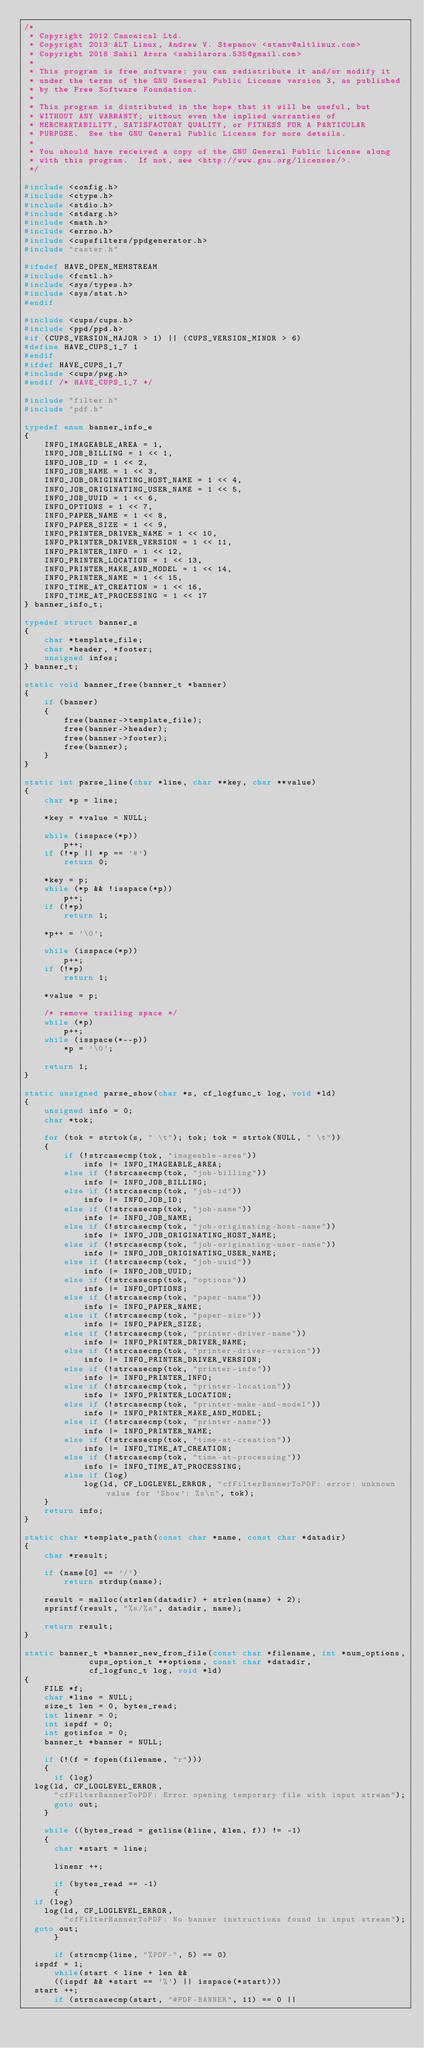Convert code to text. <code><loc_0><loc_0><loc_500><loc_500><_C_>/*
 * Copyright 2012 Canonical Ltd.
 * Copyright 2013 ALT Linux, Andrew V. Stepanov <stanv@altlinux.com>
 * Copyright 2018 Sahil Arora <sahilarora.535@gmail.com>
 *
 * This program is free software: you can redistribute it and/or modify it
 * under the terms of the GNU General Public License version 3, as published
 * by the Free Software Foundation.
 *
 * This program is distributed in the hope that it will be useful, but
 * WITHOUT ANY WARRANTY; without even the implied warranties of
 * MERCHANTABILITY, SATISFACTORY QUALITY, or FITNESS FOR A PARTICULAR
 * PURPOSE.  See the GNU General Public License for more details.
 *
 * You should have received a copy of the GNU General Public License along
 * with this program.  If not, see <http://www.gnu.org/licenses/>.
 */

#include <config.h>
#include <ctype.h>
#include <stdio.h>
#include <stdarg.h>
#include <math.h>
#include <errno.h>
#include <cupsfilters/ppdgenerator.h>
#include "raster.h"

#ifndef HAVE_OPEN_MEMSTREAM
#include <fcntl.h>
#include <sys/types.h>
#include <sys/stat.h>
#endif

#include <cups/cups.h>
#include <ppd/ppd.h>
#if (CUPS_VERSION_MAJOR > 1) || (CUPS_VERSION_MINOR > 6)
#define HAVE_CUPS_1_7 1
#endif
#ifdef HAVE_CUPS_1_7
#include <cups/pwg.h>
#endif /* HAVE_CUPS_1_7 */

#include "filter.h"
#include "pdf.h"

typedef enum banner_info_e
{
    INFO_IMAGEABLE_AREA = 1,
    INFO_JOB_BILLING = 1 << 1,
    INFO_JOB_ID = 1 << 2,
    INFO_JOB_NAME = 1 << 3,
    INFO_JOB_ORIGINATING_HOST_NAME = 1 << 4,
    INFO_JOB_ORIGINATING_USER_NAME = 1 << 5,
    INFO_JOB_UUID = 1 << 6,
    INFO_OPTIONS = 1 << 7,
    INFO_PAPER_NAME = 1 << 8,
    INFO_PAPER_SIZE = 1 << 9,
    INFO_PRINTER_DRIVER_NAME = 1 << 10,
    INFO_PRINTER_DRIVER_VERSION = 1 << 11,
    INFO_PRINTER_INFO = 1 << 12,
    INFO_PRINTER_LOCATION = 1 << 13,
    INFO_PRINTER_MAKE_AND_MODEL = 1 << 14,
    INFO_PRINTER_NAME = 1 << 15,
    INFO_TIME_AT_CREATION = 1 << 16,
    INFO_TIME_AT_PROCESSING = 1 << 17
} banner_info_t;

typedef struct banner_s
{
    char *template_file;
    char *header, *footer;
    unsigned infos;
} banner_t;

static void banner_free(banner_t *banner)
{
    if (banner)
    {
        free(banner->template_file);
        free(banner->header);
        free(banner->footer);
        free(banner);
    }
}

static int parse_line(char *line, char **key, char **value)
{
    char *p = line;

    *key = *value = NULL;

    while (isspace(*p))
        p++;
    if (!*p || *p == '#')
        return 0;

    *key = p;
    while (*p && !isspace(*p))
        p++;
    if (!*p)
        return 1;

    *p++ = '\0';

    while (isspace(*p))
        p++;
    if (!*p)
        return 1;

    *value = p;

    /* remove trailing space */
    while (*p)
        p++;
    while (isspace(*--p))
        *p = '\0';

    return 1;
}

static unsigned parse_show(char *s, cf_logfunc_t log, void *ld)
{
    unsigned info = 0;
    char *tok;

    for (tok = strtok(s, " \t"); tok; tok = strtok(NULL, " \t"))
    {
        if (!strcasecmp(tok, "imageable-area"))
            info |= INFO_IMAGEABLE_AREA;
        else if (!strcasecmp(tok, "job-billing"))
            info |= INFO_JOB_BILLING;
        else if (!strcasecmp(tok, "job-id"))
            info |= INFO_JOB_ID;
        else if (!strcasecmp(tok, "job-name"))
            info |= INFO_JOB_NAME;
        else if (!strcasecmp(tok, "job-originating-host-name"))
            info |= INFO_JOB_ORIGINATING_HOST_NAME;
        else if (!strcasecmp(tok, "job-originating-user-name"))
            info |= INFO_JOB_ORIGINATING_USER_NAME;
        else if (!strcasecmp(tok, "job-uuid"))
            info |= INFO_JOB_UUID;
        else if (!strcasecmp(tok, "options"))
            info |= INFO_OPTIONS;
        else if (!strcasecmp(tok, "paper-name"))
            info |= INFO_PAPER_NAME;
        else if (!strcasecmp(tok, "paper-size"))
            info |= INFO_PAPER_SIZE;
        else if (!strcasecmp(tok, "printer-driver-name"))
            info |= INFO_PRINTER_DRIVER_NAME;
        else if (!strcasecmp(tok, "printer-driver-version"))
            info |= INFO_PRINTER_DRIVER_VERSION;
        else if (!strcasecmp(tok, "printer-info"))
            info |= INFO_PRINTER_INFO;
        else if (!strcasecmp(tok, "printer-location"))
            info |= INFO_PRINTER_LOCATION;
        else if (!strcasecmp(tok, "printer-make-and-model"))
            info |= INFO_PRINTER_MAKE_AND_MODEL;
        else if (!strcasecmp(tok, "printer-name"))
            info |= INFO_PRINTER_NAME;
        else if (!strcasecmp(tok, "time-at-creation"))
            info |= INFO_TIME_AT_CREATION;
        else if (!strcasecmp(tok, "time-at-processing"))
            info |= INFO_TIME_AT_PROCESSING;
        else if (log)
            log(ld, CF_LOGLEVEL_ERROR, "cfFilterBannerToPDF: error: unknown value for 'Show': %s\n", tok);
    }
    return info;
}

static char *template_path(const char *name, const char *datadir)
{
    char *result;

    if (name[0] == '/')
        return strdup(name);

    result = malloc(strlen(datadir) + strlen(name) + 2);
    sprintf(result, "%s/%s", datadir, name);

    return result;
}

static banner_t *banner_new_from_file(const char *filename, int *num_options,
			       cups_option_t **options, const char *datadir,
			       cf_logfunc_t log, void *ld)
{
    FILE *f;
    char *line = NULL;
    size_t len = 0, bytes_read;
    int linenr = 0;
    int ispdf = 0;
    int gotinfos = 0;
    banner_t *banner = NULL;

    if (!(f = fopen(filename, "r")))
    {
      if (log)
	log(ld, CF_LOGLEVEL_ERROR,
	    "cfFilterBannerToPDF: Error opening temporary file with input stream");
      goto out;
    }

    while ((bytes_read = getline(&line, &len, f)) != -1)
    {
      char *start = line;

      linenr ++;

      if (bytes_read == -1)
      {
	if (log)
	  log(ld, CF_LOGLEVEL_ERROR,
	      "cfFilterBannerToPDF: No banner instructions found in input stream");
	goto out;
      }

      if (strncmp(line, "%PDF-", 5) == 0)
	ispdf = 1;
      while(start < line + len &&
	    ((ispdf && *start == '%') || isspace(*start)))
	start ++;
      if (strncasecmp(start, "#PDF-BANNER", 11) == 0 ||</code> 